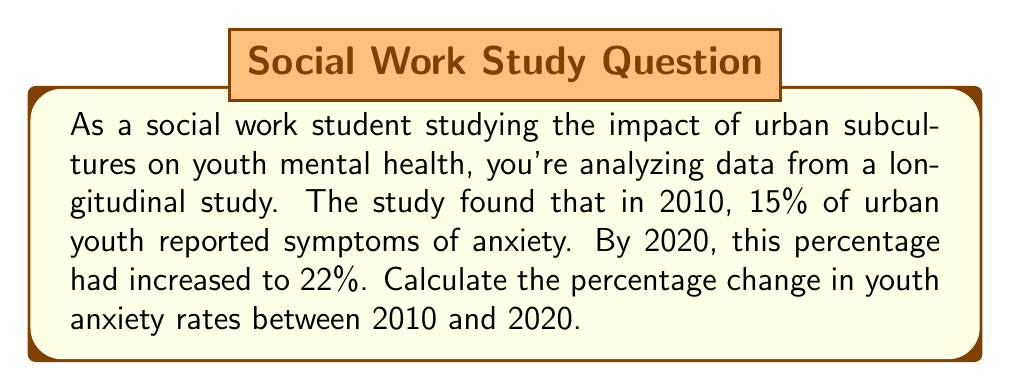Could you help me with this problem? To calculate the percentage change, we'll use the following formula:

$$ \text{Percentage Change} = \frac{\text{New Value} - \text{Original Value}}{\text{Original Value}} \times 100\% $$

Let's plug in our values:
- Original Value (2010): 15%
- New Value (2020): 22%

$$ \text{Percentage Change} = \frac{22\% - 15\%}{15\%} \times 100\% $$

$$ = \frac{7\%}{15\%} \times 100\% $$

$$ = 0.4666... \times 100\% $$

$$ = 46.67\% $$

Rounding to two decimal places, we get 46.67%.

This means the rate of youth reporting anxiety symptoms increased by approximately 46.67% between 2010 and 2020.
Answer: The percentage change in youth anxiety rates between 2010 and 2020 is an increase of 46.67%. 